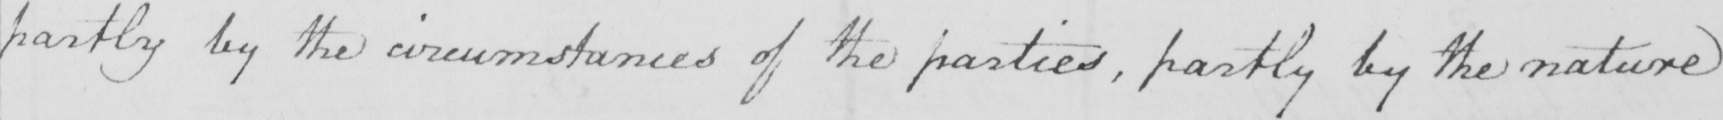Please transcribe the handwritten text in this image. partly by the circumstances of the parties , partly by the nature 